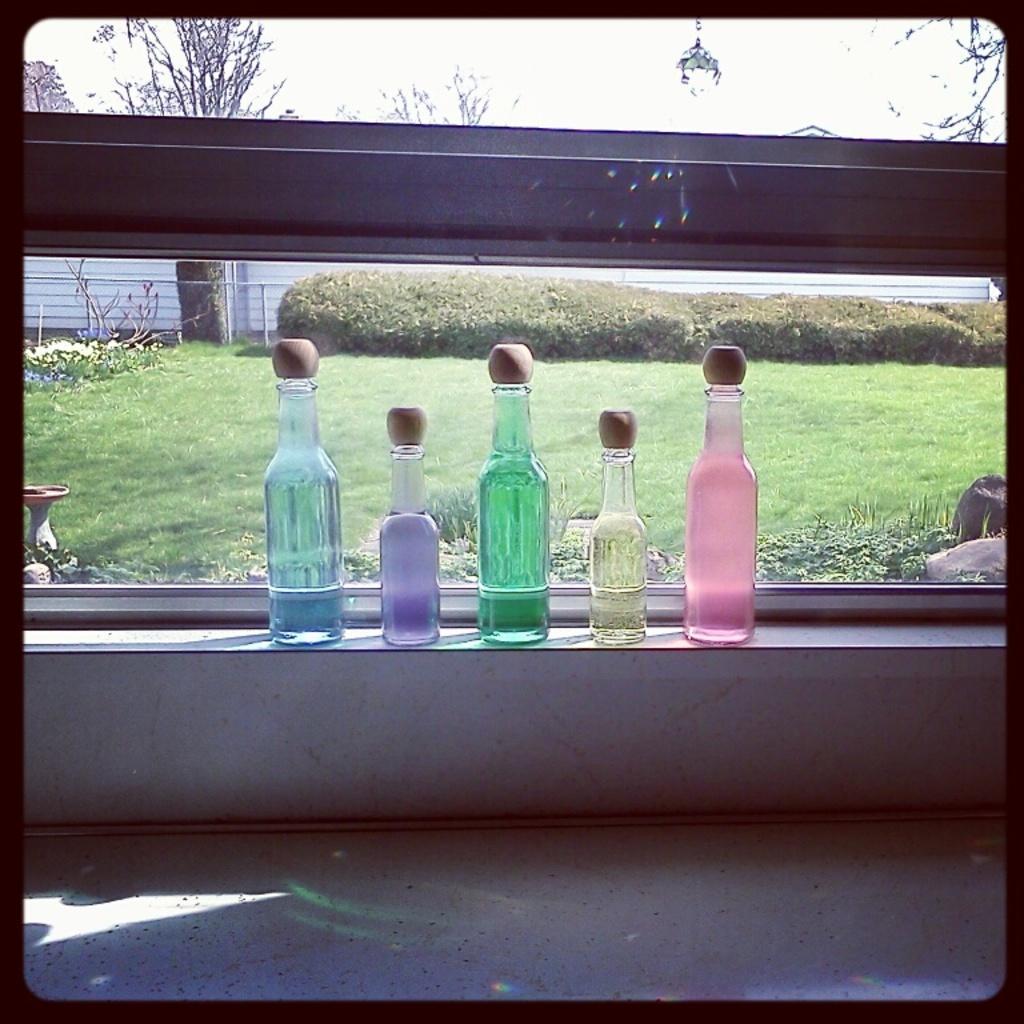Can you describe this image briefly? In this picture we can see bottles of different colors placed on some wall and from this glass we can see grass, trees, rods. 